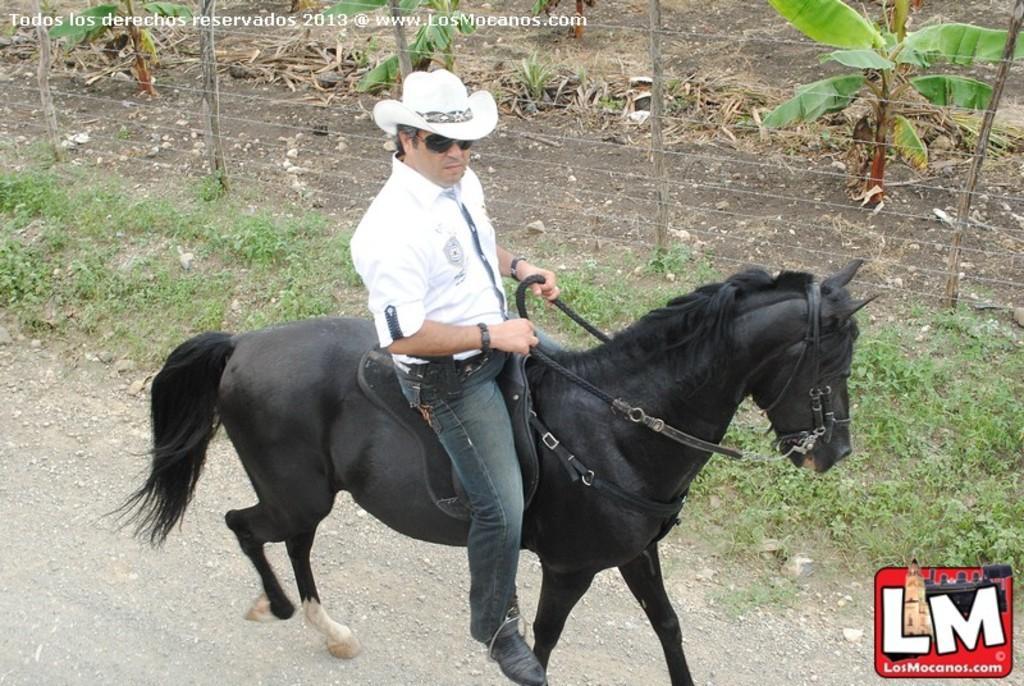In one or two sentences, can you explain what this image depicts? This is an outside view. Here I can see a man wearing white color t-shirt, jeans, cap on the head and sitting on a horse which is in black color and it is walking on the road towards the right side. Beside the road I can see the grass. In the background there are some trees on the ground and also I can see a fencing. 